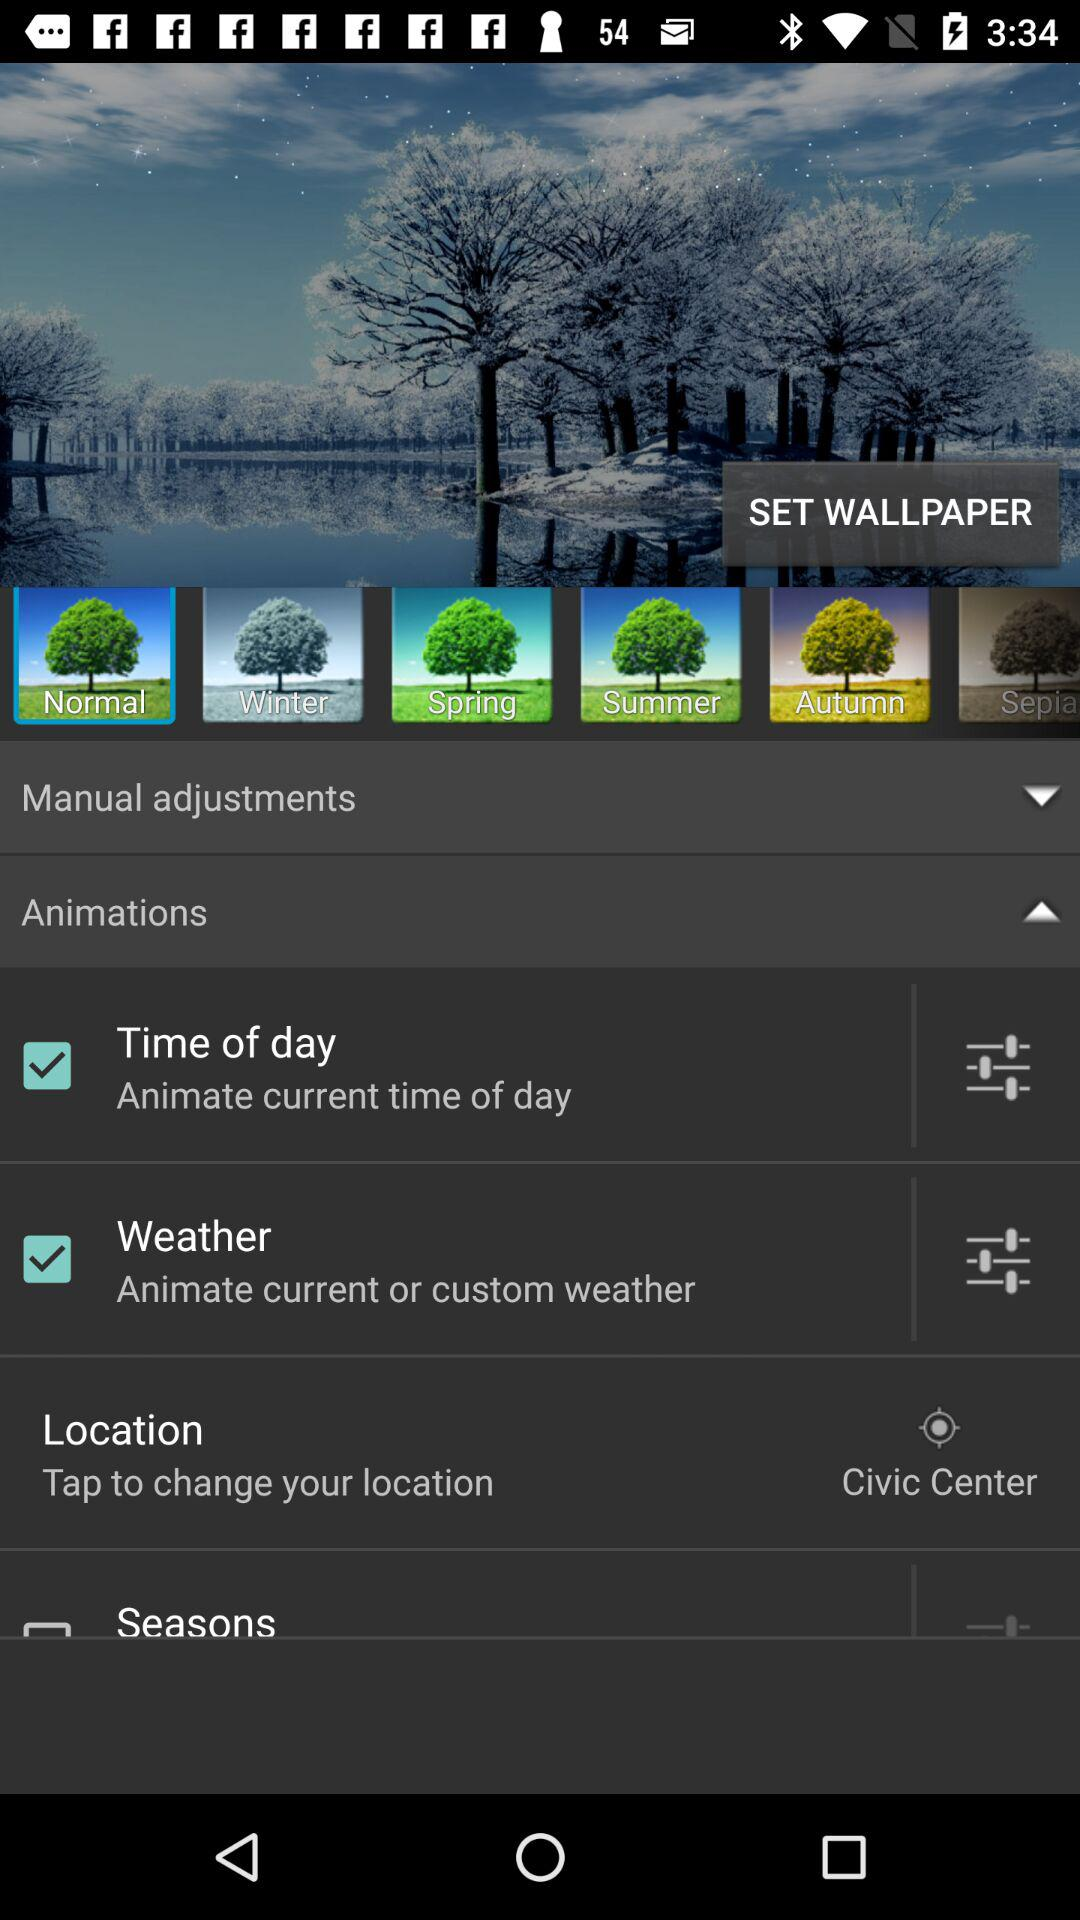What options are checked in "Animations"? The options that are checked are "Time of day" and "Weather". 